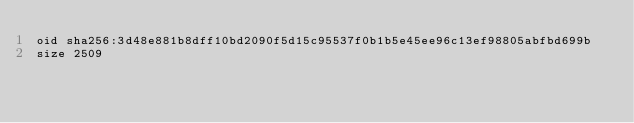<code> <loc_0><loc_0><loc_500><loc_500><_YAML_>oid sha256:3d48e881b8dff10bd2090f5d15c95537f0b1b5e45ee96c13ef98805abfbd699b
size 2509
</code> 